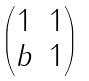<formula> <loc_0><loc_0><loc_500><loc_500>\begin{pmatrix} 1 & 1 \\ b & 1 \end{pmatrix}</formula> 